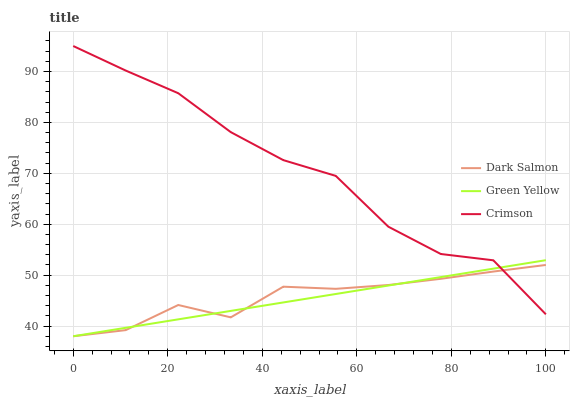Does Green Yellow have the minimum area under the curve?
Answer yes or no. Yes. Does Crimson have the maximum area under the curve?
Answer yes or no. Yes. Does Dark Salmon have the minimum area under the curve?
Answer yes or no. No. Does Dark Salmon have the maximum area under the curve?
Answer yes or no. No. Is Green Yellow the smoothest?
Answer yes or no. Yes. Is Crimson the roughest?
Answer yes or no. Yes. Is Dark Salmon the smoothest?
Answer yes or no. No. Is Dark Salmon the roughest?
Answer yes or no. No. Does Green Yellow have the lowest value?
Answer yes or no. Yes. Does Crimson have the highest value?
Answer yes or no. Yes. Does Green Yellow have the highest value?
Answer yes or no. No. Does Crimson intersect Green Yellow?
Answer yes or no. Yes. Is Crimson less than Green Yellow?
Answer yes or no. No. Is Crimson greater than Green Yellow?
Answer yes or no. No. 